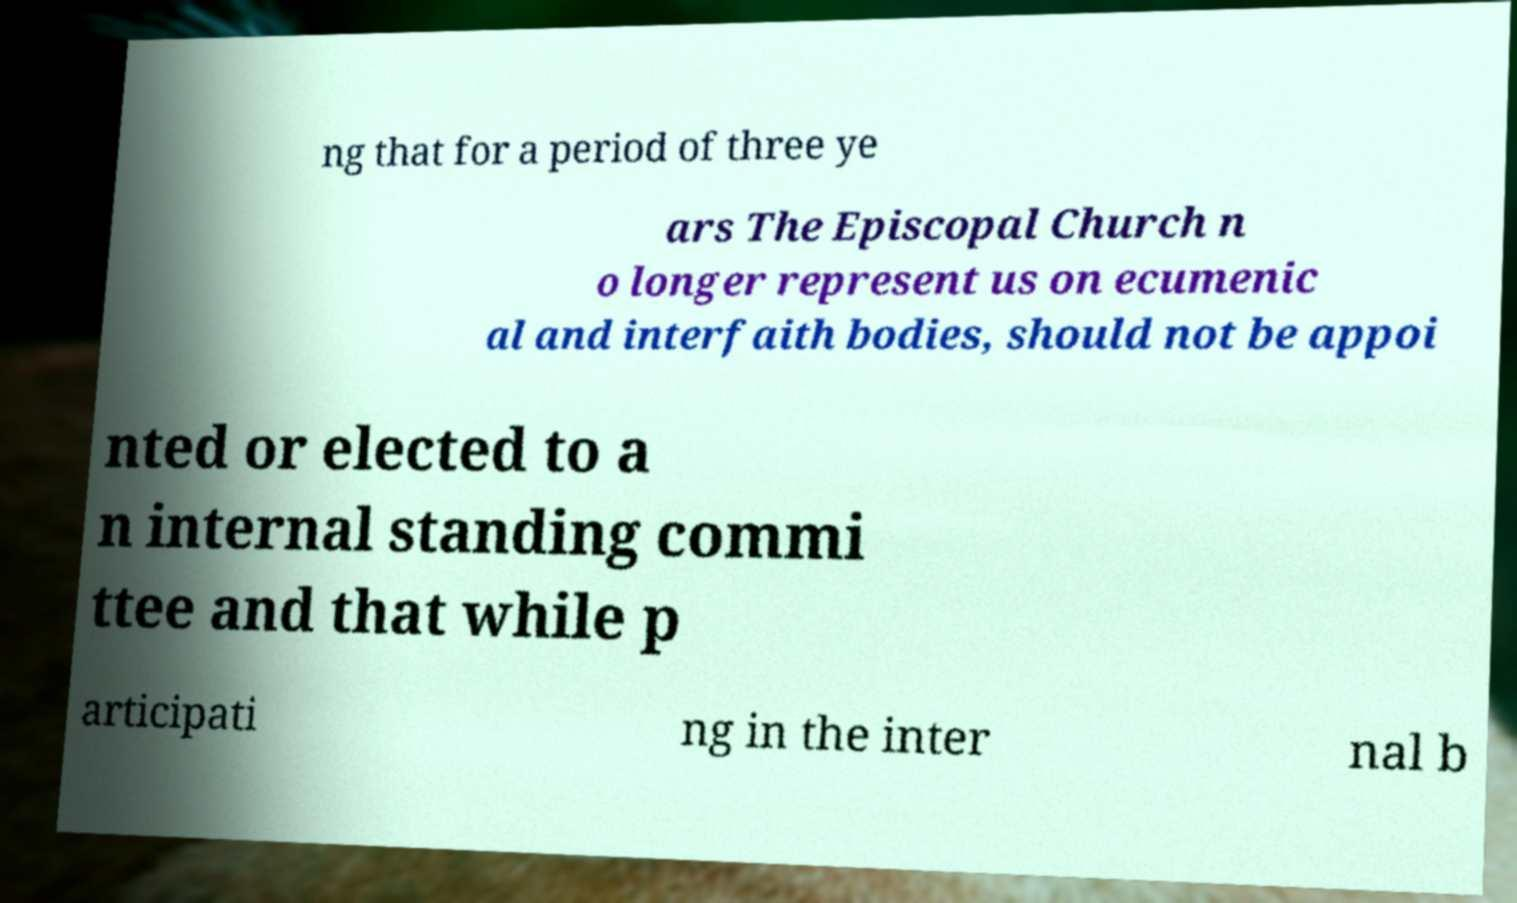I need the written content from this picture converted into text. Can you do that? ng that for a period of three ye ars The Episcopal Church n o longer represent us on ecumenic al and interfaith bodies, should not be appoi nted or elected to a n internal standing commi ttee and that while p articipati ng in the inter nal b 